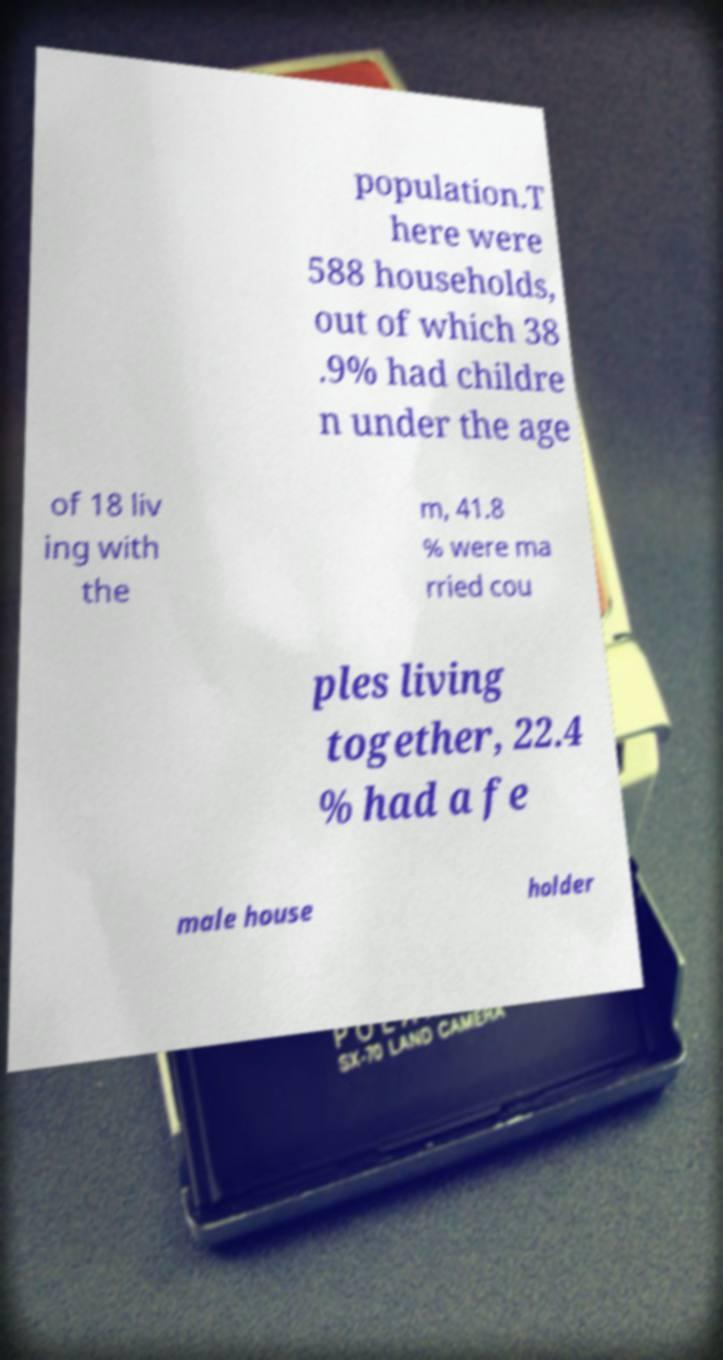Can you accurately transcribe the text from the provided image for me? population.T here were 588 households, out of which 38 .9% had childre n under the age of 18 liv ing with the m, 41.8 % were ma rried cou ples living together, 22.4 % had a fe male house holder 